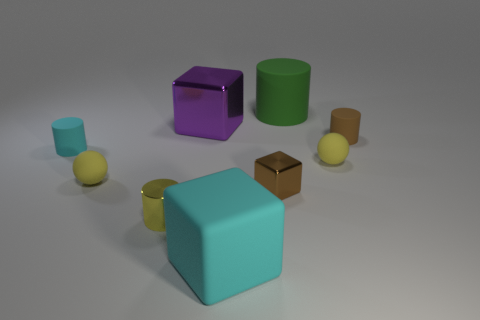There is a cylinder that is on the right side of the green cylinder; does it have the same color as the shiny cube that is in front of the brown rubber cylinder?
Your answer should be very brief. Yes. What number of matte things are small gray objects or cyan things?
Your answer should be very brief. 2. What number of small brown things are in front of the metallic cube behind the yellow matte thing that is right of the cyan matte block?
Offer a very short reply. 2. There is a green cylinder that is made of the same material as the big cyan thing; what size is it?
Keep it short and to the point. Large. How many other metal objects are the same color as the large metallic thing?
Offer a terse response. 0. Does the sphere on the right side of the yellow metallic object have the same size as the small cyan cylinder?
Ensure brevity in your answer.  Yes. What color is the small matte thing that is left of the brown cylinder and right of the big green object?
Keep it short and to the point. Yellow. How many objects are large green metal things or matte balls that are left of the small yellow metallic object?
Make the answer very short. 1. There is a cyan object to the right of the big purple thing behind the cylinder that is to the right of the big green thing; what is it made of?
Keep it short and to the point. Rubber. Is the color of the small matte sphere that is right of the big cylinder the same as the small metal cylinder?
Your answer should be very brief. Yes. 